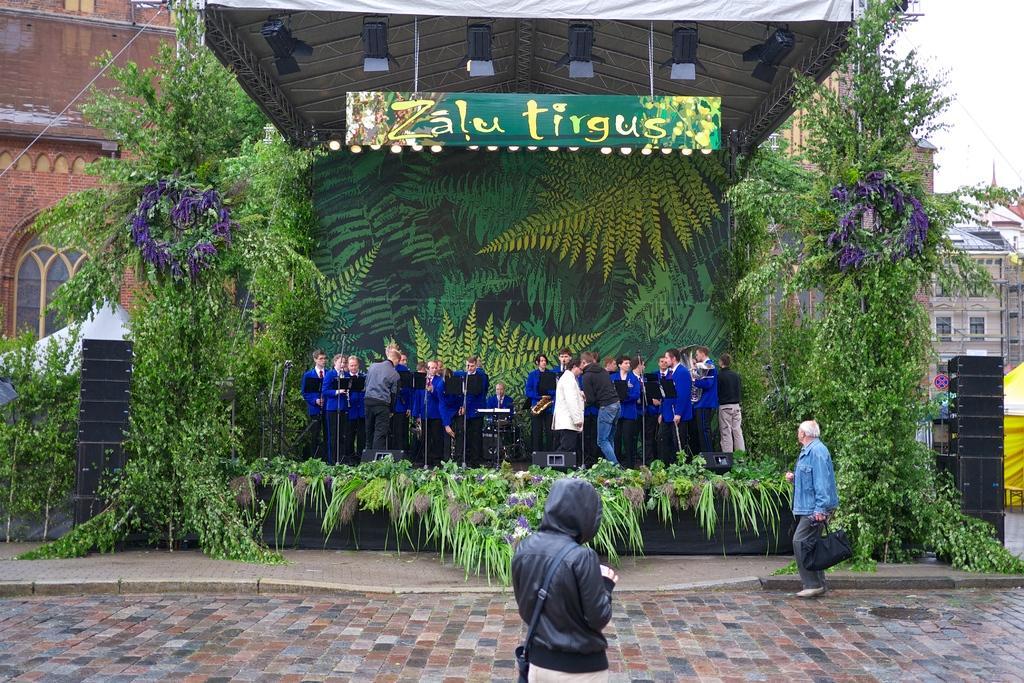Describe this image in one or two sentences. At the bottom of the image two persons are standing. In the middle of the image few people are standing and sitting and they are holding some musical instruments and there are some plants. Behind them there is banner. At the top of the image there is roof and banner. Behind the banner there are some buildings. In the top right corner of the image there is sky. 